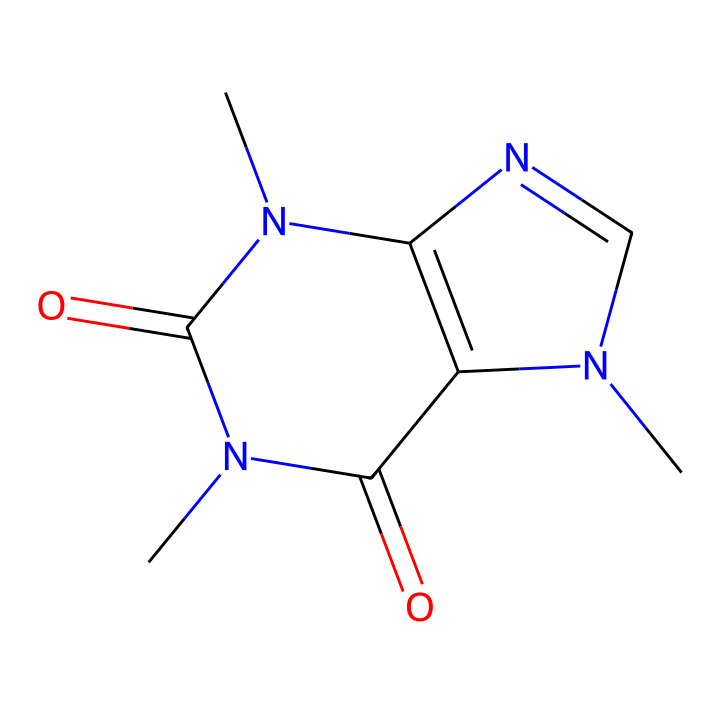What is the molecular formula of caffeine? To determine the molecular formula, count the number of each type of atom in the SMILES representation. The structure contains 8 carbons (C), 10 hydrogens (H), 4 nitrogens (N), and 2 oxygens (O), leading to the formula C8H10N4O2.
Answer: C8H10N4O2 How many nitrogen atoms are present in caffeine? In the provided SMILES representation, identify the nitrogen atoms represented by 'N' in the structure. There are 4 nitrogen atoms in the structure.
Answer: 4 What functional groups are present in caffeine? Examine the structure to identify functional groups. Caffeine contains amide groups and an imidazole ring, which are characteristic of its structure.
Answer: amide, imidazole Is caffeine an alkaloid? Alkaloids are primarily nitrogen-containing compounds with significant pharmacological effects. The presence of nitrogen and its psychoactive properties confirm caffeine is an alkaloid.
Answer: yes Which ring structure is present in caffeine? Analyze the rings in the chemical structure. Caffeine contains a fused bicyclic ring system, including a pyrimidine and an imidazole ring structure.
Answer: bicyclic What is the primary effect of caffeine on the human body? Caffeine primarily acts as a stimulant by blocking adenosine receptors, which increases alertness and reduces fatigue.
Answer: stimulant 